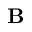Convert formula to latex. <formula><loc_0><loc_0><loc_500><loc_500>{ B }</formula> 